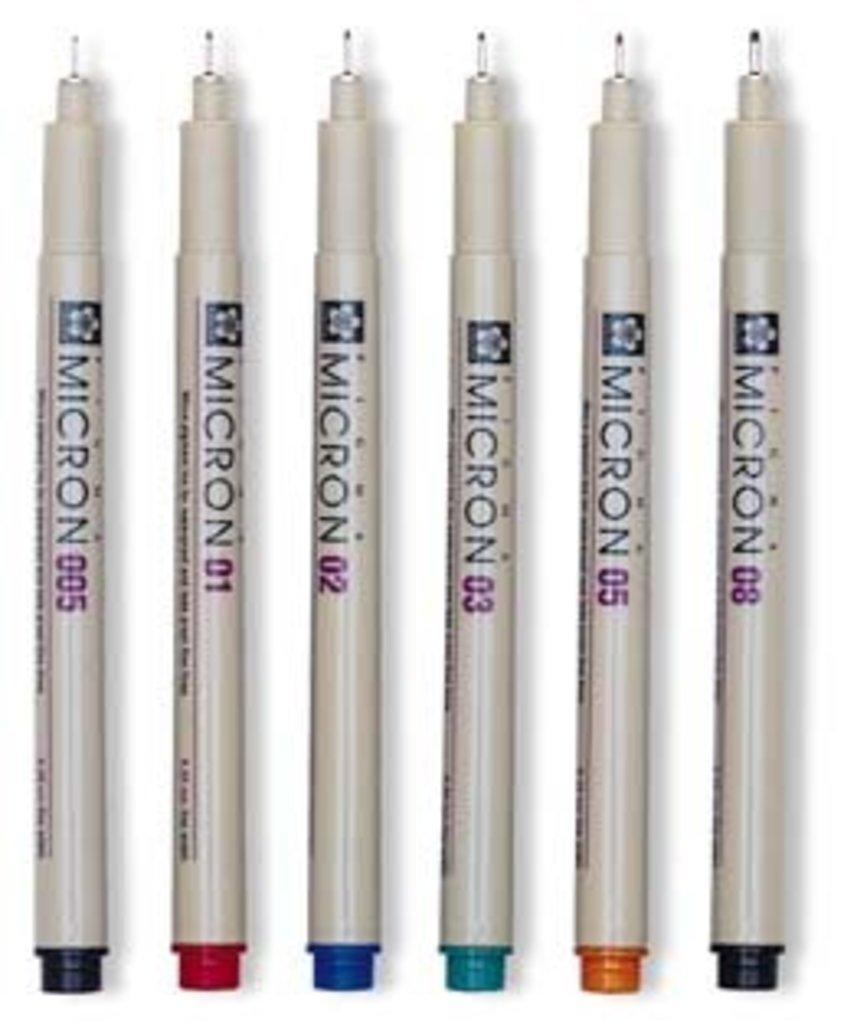How many pens are visible in the image? There are six pens in the image. What can be observed about the pens in terms of their appearance? The pens are in different colors. What is the color of the background in the image? The background of the image is white. Can you see a baby playing with the pens in the image? There is no baby present in the image; it only features six pens in different colors against a white background. 